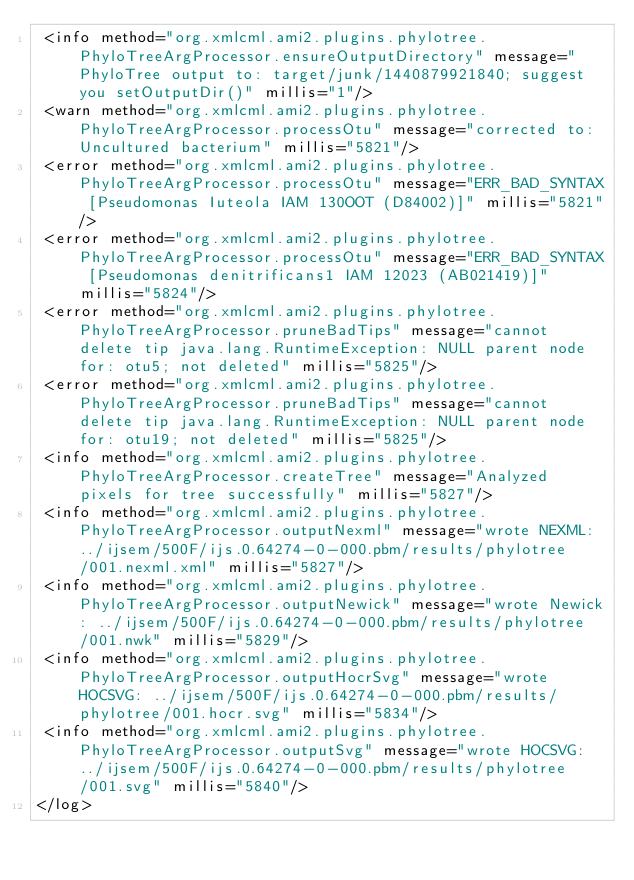Convert code to text. <code><loc_0><loc_0><loc_500><loc_500><_XML_> <info method="org.xmlcml.ami2.plugins.phylotree.PhyloTreeArgProcessor.ensureOutputDirectory" message="PhyloTree output to: target/junk/1440879921840; suggest you setOutputDir()" millis="1"/>
 <warn method="org.xmlcml.ami2.plugins.phylotree.PhyloTreeArgProcessor.processOtu" message="corrected to: Uncultured bacterium" millis="5821"/>
 <error method="org.xmlcml.ami2.plugins.phylotree.PhyloTreeArgProcessor.processOtu" message="ERR_BAD_SYNTAX [Pseudomonas Iuteola IAM 130OOT (D84002)]" millis="5821"/>
 <error method="org.xmlcml.ami2.plugins.phylotree.PhyloTreeArgProcessor.processOtu" message="ERR_BAD_SYNTAX [Pseudomonas denitrificans1 IAM 12023 (AB021419)]" millis="5824"/>
 <error method="org.xmlcml.ami2.plugins.phylotree.PhyloTreeArgProcessor.pruneBadTips" message="cannot delete tip java.lang.RuntimeException: NULL parent node for: otu5; not deleted" millis="5825"/>
 <error method="org.xmlcml.ami2.plugins.phylotree.PhyloTreeArgProcessor.pruneBadTips" message="cannot delete tip java.lang.RuntimeException: NULL parent node for: otu19; not deleted" millis="5825"/>
 <info method="org.xmlcml.ami2.plugins.phylotree.PhyloTreeArgProcessor.createTree" message="Analyzed pixels for tree successfully" millis="5827"/>
 <info method="org.xmlcml.ami2.plugins.phylotree.PhyloTreeArgProcessor.outputNexml" message="wrote NEXML: ../ijsem/500F/ijs.0.64274-0-000.pbm/results/phylotree/001.nexml.xml" millis="5827"/>
 <info method="org.xmlcml.ami2.plugins.phylotree.PhyloTreeArgProcessor.outputNewick" message="wrote Newick: ../ijsem/500F/ijs.0.64274-0-000.pbm/results/phylotree/001.nwk" millis="5829"/>
 <info method="org.xmlcml.ami2.plugins.phylotree.PhyloTreeArgProcessor.outputHocrSvg" message="wrote HOCSVG: ../ijsem/500F/ijs.0.64274-0-000.pbm/results/phylotree/001.hocr.svg" millis="5834"/>
 <info method="org.xmlcml.ami2.plugins.phylotree.PhyloTreeArgProcessor.outputSvg" message="wrote HOCSVG: ../ijsem/500F/ijs.0.64274-0-000.pbm/results/phylotree/001.svg" millis="5840"/>
</log>
</code> 